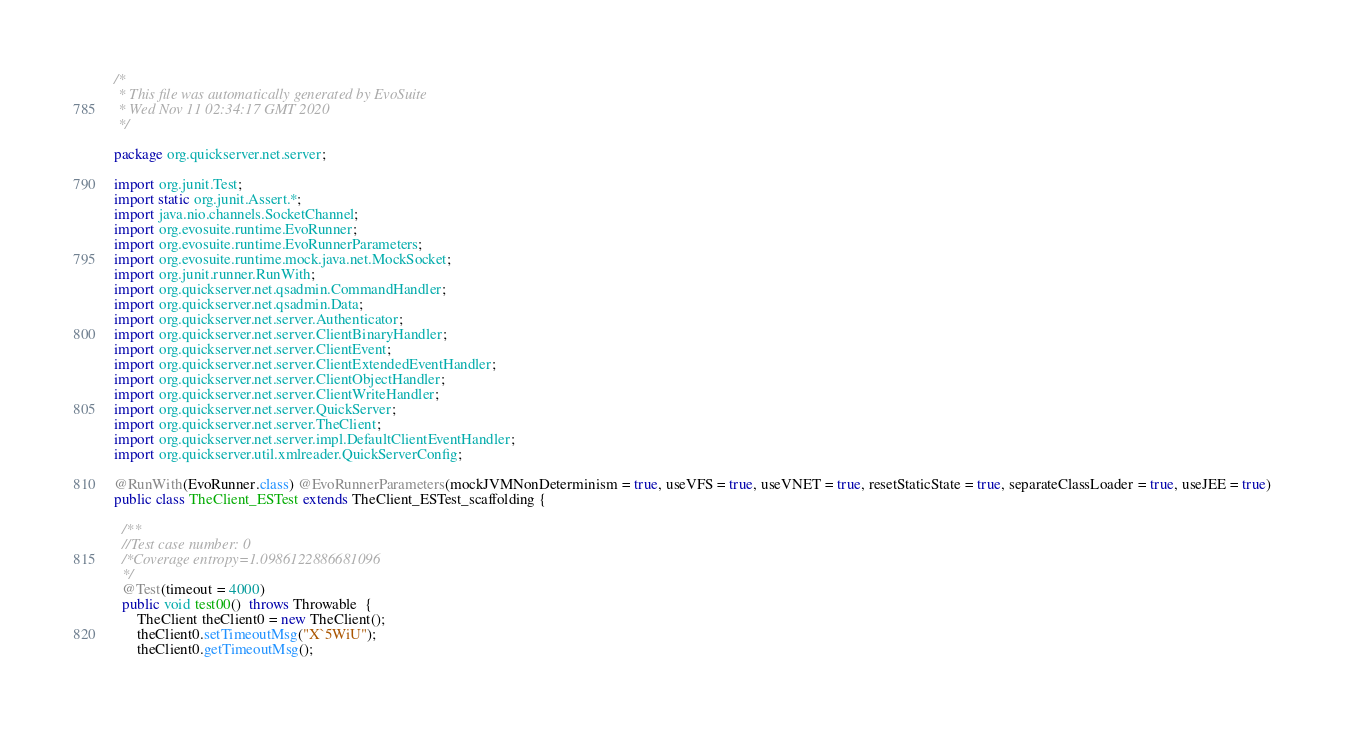<code> <loc_0><loc_0><loc_500><loc_500><_Java_>/*
 * This file was automatically generated by EvoSuite
 * Wed Nov 11 02:34:17 GMT 2020
 */

package org.quickserver.net.server;

import org.junit.Test;
import static org.junit.Assert.*;
import java.nio.channels.SocketChannel;
import org.evosuite.runtime.EvoRunner;
import org.evosuite.runtime.EvoRunnerParameters;
import org.evosuite.runtime.mock.java.net.MockSocket;
import org.junit.runner.RunWith;
import org.quickserver.net.qsadmin.CommandHandler;
import org.quickserver.net.qsadmin.Data;
import org.quickserver.net.server.Authenticator;
import org.quickserver.net.server.ClientBinaryHandler;
import org.quickserver.net.server.ClientEvent;
import org.quickserver.net.server.ClientExtendedEventHandler;
import org.quickserver.net.server.ClientObjectHandler;
import org.quickserver.net.server.ClientWriteHandler;
import org.quickserver.net.server.QuickServer;
import org.quickserver.net.server.TheClient;
import org.quickserver.net.server.impl.DefaultClientEventHandler;
import org.quickserver.util.xmlreader.QuickServerConfig;

@RunWith(EvoRunner.class) @EvoRunnerParameters(mockJVMNonDeterminism = true, useVFS = true, useVNET = true, resetStaticState = true, separateClassLoader = true, useJEE = true) 
public class TheClient_ESTest extends TheClient_ESTest_scaffolding {

  /**
  //Test case number: 0
  /*Coverage entropy=1.0986122886681096
  */
  @Test(timeout = 4000)
  public void test00()  throws Throwable  {
      TheClient theClient0 = new TheClient();
      theClient0.setTimeoutMsg("X`5WiU");
      theClient0.getTimeoutMsg();</code> 